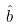<formula> <loc_0><loc_0><loc_500><loc_500>\hat { b }</formula> 